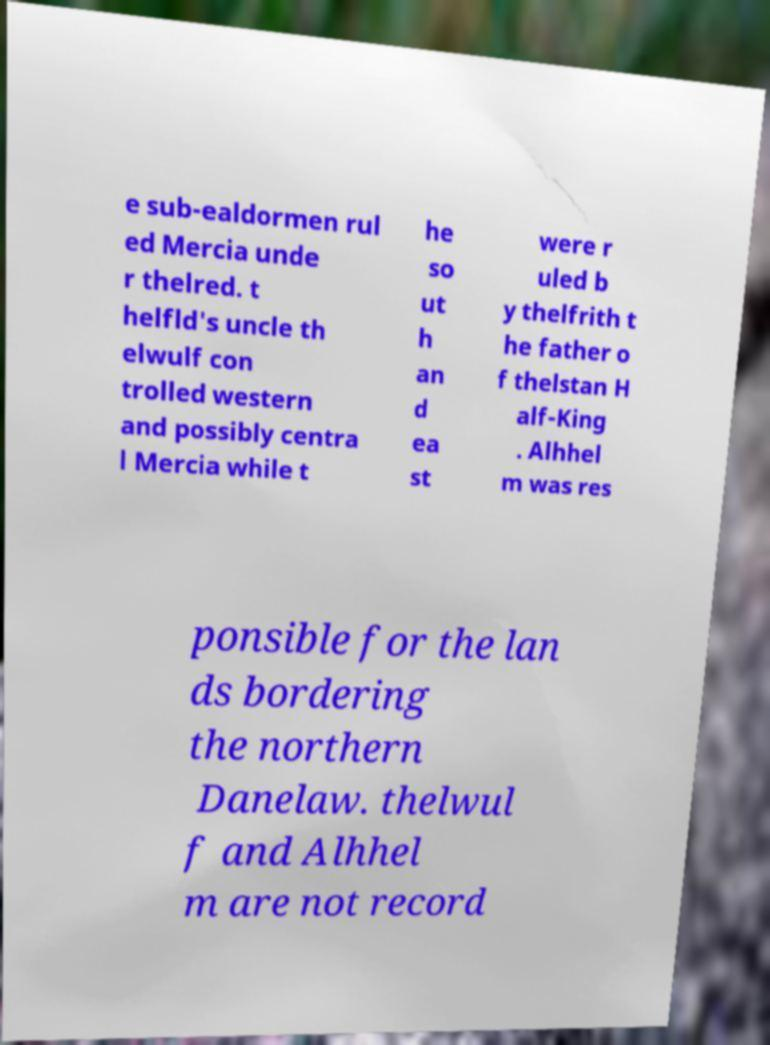I need the written content from this picture converted into text. Can you do that? e sub-ealdormen rul ed Mercia unde r thelred. t helfld's uncle th elwulf con trolled western and possibly centra l Mercia while t he so ut h an d ea st were r uled b y thelfrith t he father o f thelstan H alf-King . Alhhel m was res ponsible for the lan ds bordering the northern Danelaw. thelwul f and Alhhel m are not record 